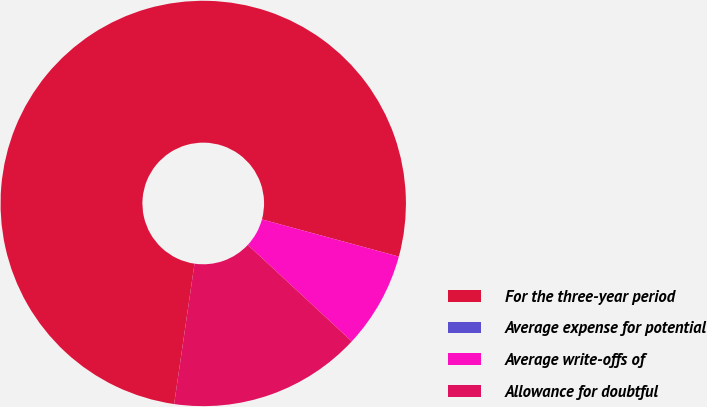Convert chart. <chart><loc_0><loc_0><loc_500><loc_500><pie_chart><fcel>For the three-year period<fcel>Average expense for potential<fcel>Average write-offs of<fcel>Allowance for doubtful<nl><fcel>76.92%<fcel>0.0%<fcel>7.69%<fcel>15.38%<nl></chart> 